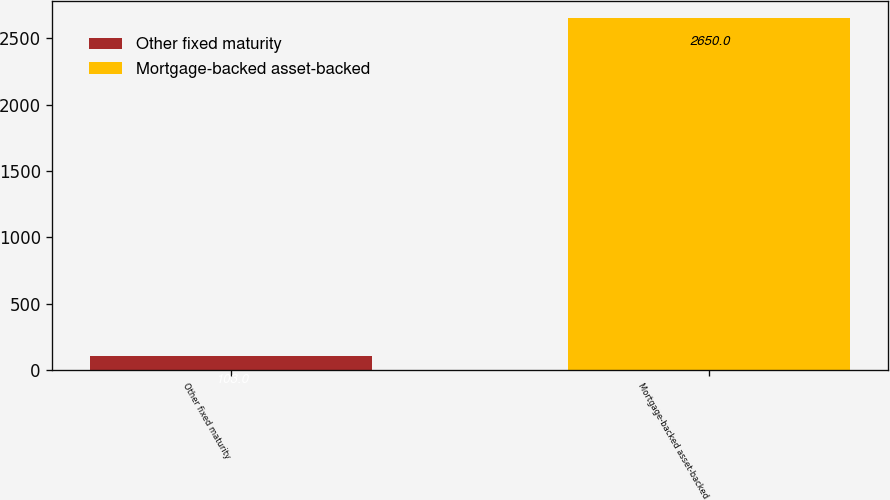Convert chart to OTSL. <chart><loc_0><loc_0><loc_500><loc_500><bar_chart><fcel>Other fixed maturity<fcel>Mortgage-backed asset-backed<nl><fcel>103<fcel>2650<nl></chart> 